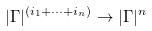Convert formula to latex. <formula><loc_0><loc_0><loc_500><loc_500>| \Gamma | ^ { ( i _ { 1 } + \cdots + i _ { n } ) } \to | \Gamma | ^ { n }</formula> 